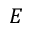Convert formula to latex. <formula><loc_0><loc_0><loc_500><loc_500>E</formula> 